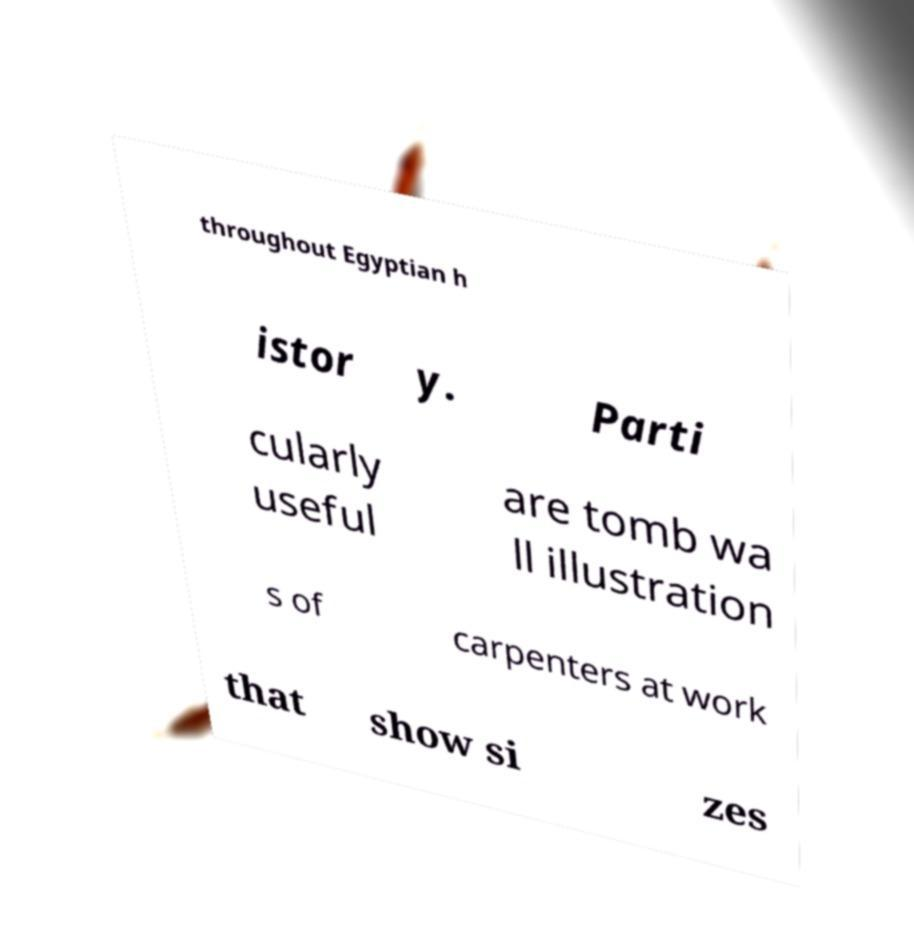What messages or text are displayed in this image? I need them in a readable, typed format. throughout Egyptian h istor y. Parti cularly useful are tomb wa ll illustration s of carpenters at work that show si zes 